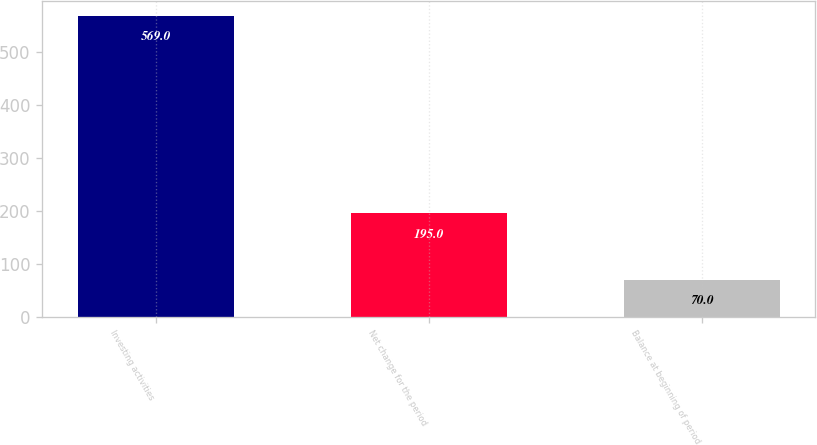Convert chart. <chart><loc_0><loc_0><loc_500><loc_500><bar_chart><fcel>Investing activities<fcel>Net change for the period<fcel>Balance at beginning of period<nl><fcel>569<fcel>195<fcel>70<nl></chart> 